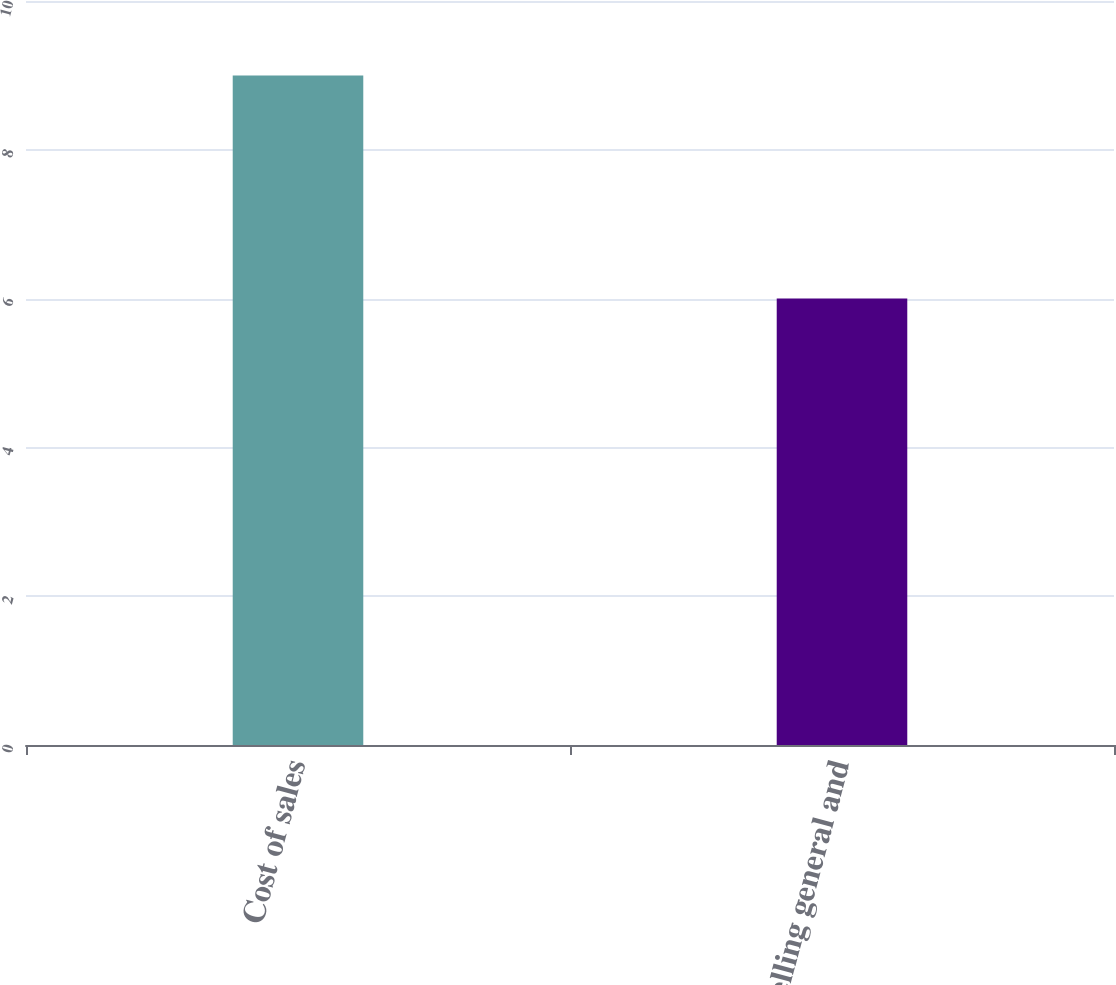Convert chart. <chart><loc_0><loc_0><loc_500><loc_500><bar_chart><fcel>Cost of sales<fcel>Selling general and<nl><fcel>9<fcel>6<nl></chart> 